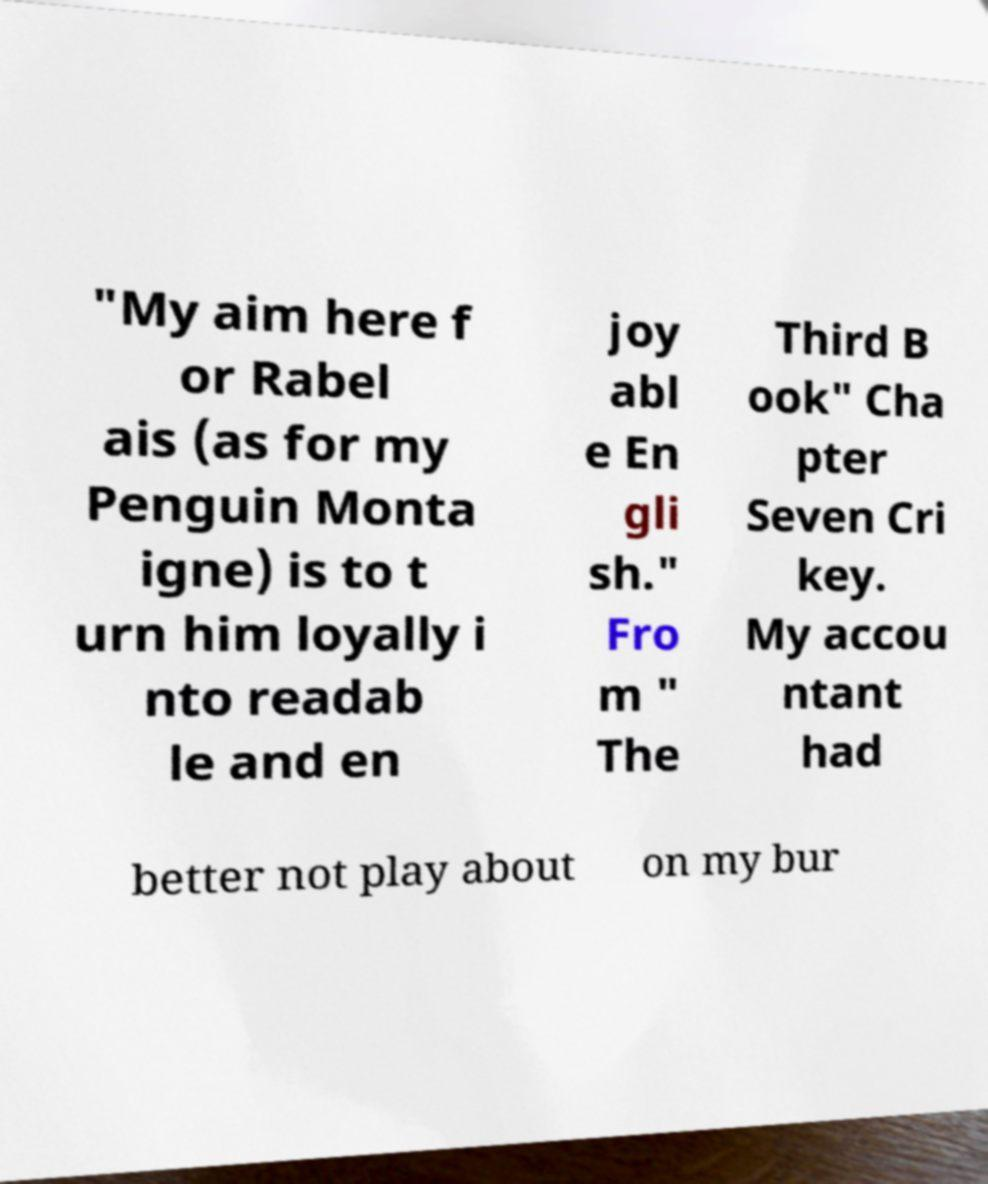Please read and relay the text visible in this image. What does it say? "My aim here f or Rabel ais (as for my Penguin Monta igne) is to t urn him loyally i nto readab le and en joy abl e En gli sh." Fro m " The Third B ook" Cha pter Seven Cri key. My accou ntant had better not play about on my bur 